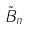Convert formula to latex. <formula><loc_0><loc_0><loc_500><loc_500>\tilde { B } _ { n }</formula> 